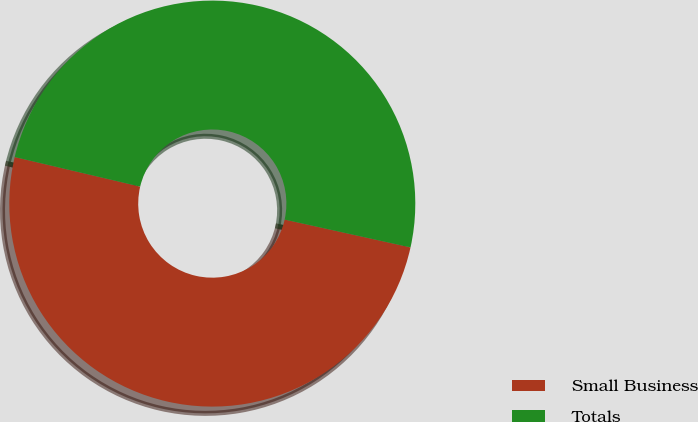Convert chart. <chart><loc_0><loc_0><loc_500><loc_500><pie_chart><fcel>Small Business<fcel>Totals<nl><fcel>50.22%<fcel>49.78%<nl></chart> 